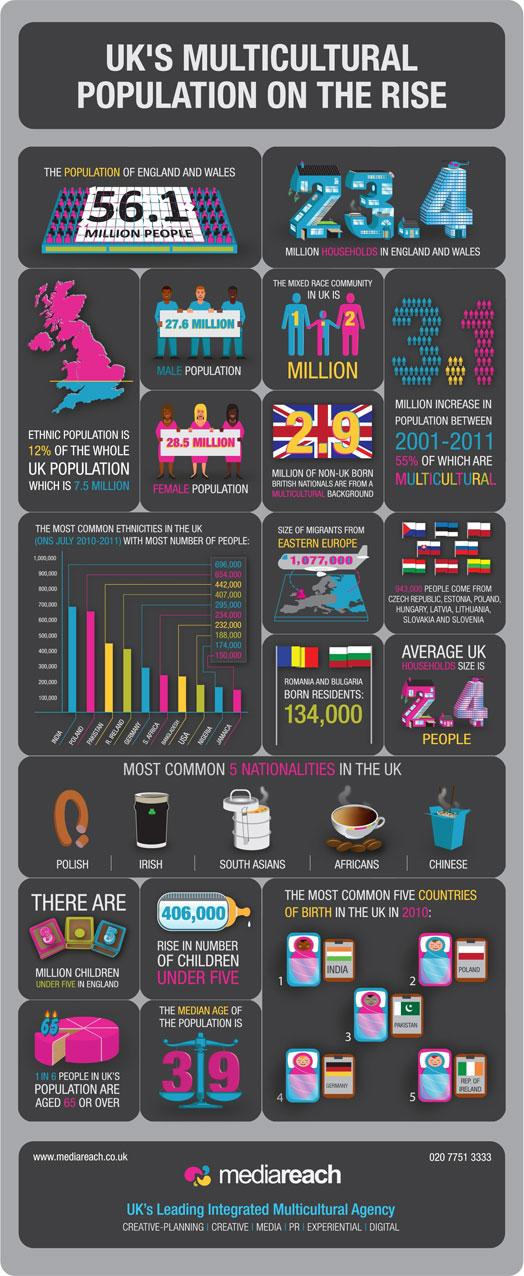Outline some significant characteristics in this image. The total male population in the United Kingdom is approximately 27.6 million. The median age of the UK population is 39 years old. The average household size in the UK is typically between 2 and 4 people, as stated. There are approximately 3.5 million children under the age of five in England. The population of the mixed race community in the UK is approximately 1.2 million. 